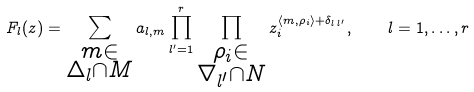Convert formula to latex. <formula><loc_0><loc_0><loc_500><loc_500>F _ { l } ( z ) = \sum _ { \substack { m \in \\ \Delta _ { l } \cap M } } a _ { l , m } \prod _ { l ^ { \prime } = 1 } ^ { r } \prod _ { \substack { \rho _ { i } \in \\ \nabla _ { l ^ { \prime } } \cap N } } z _ { i } ^ { \langle m , \rho _ { i } \rangle + \delta _ { l \, l ^ { \prime } } } , \quad l = 1 , \dots , r</formula> 